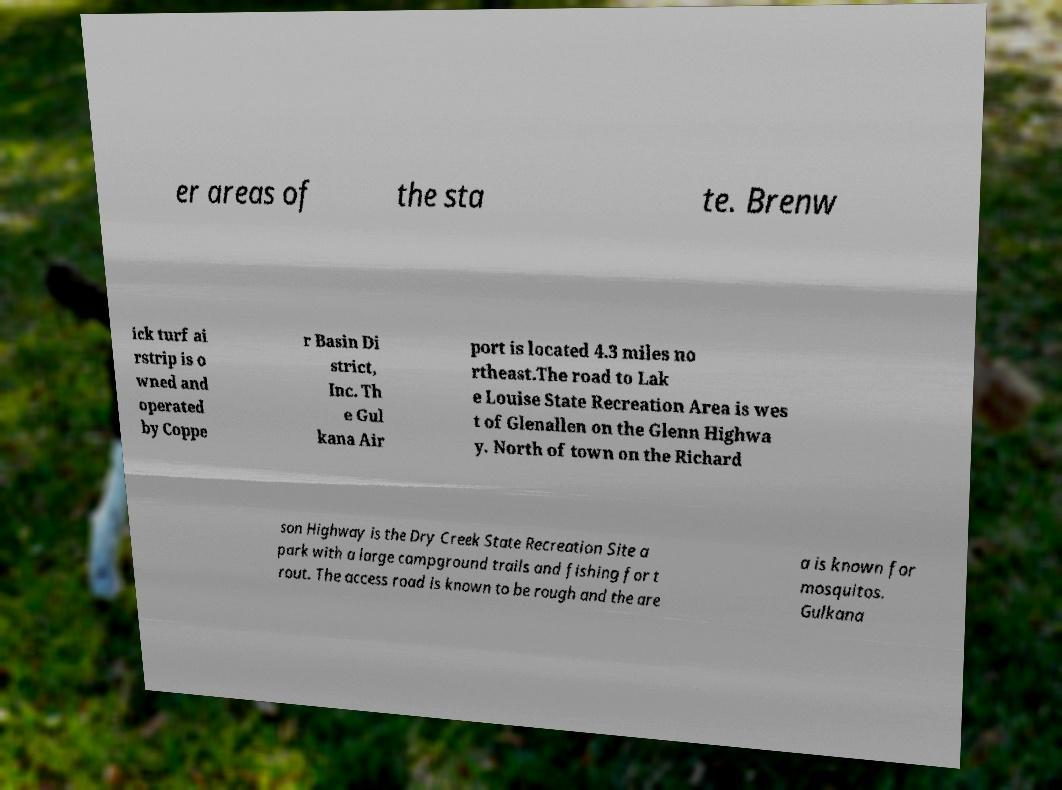Can you accurately transcribe the text from the provided image for me? er areas of the sta te. Brenw ick turf ai rstrip is o wned and operated by Coppe r Basin Di strict, Inc. Th e Gul kana Air port is located 4.3 miles no rtheast.The road to Lak e Louise State Recreation Area is wes t of Glenallen on the Glenn Highwa y. North of town on the Richard son Highway is the Dry Creek State Recreation Site a park with a large campground trails and fishing for t rout. The access road is known to be rough and the are a is known for mosquitos. Gulkana 